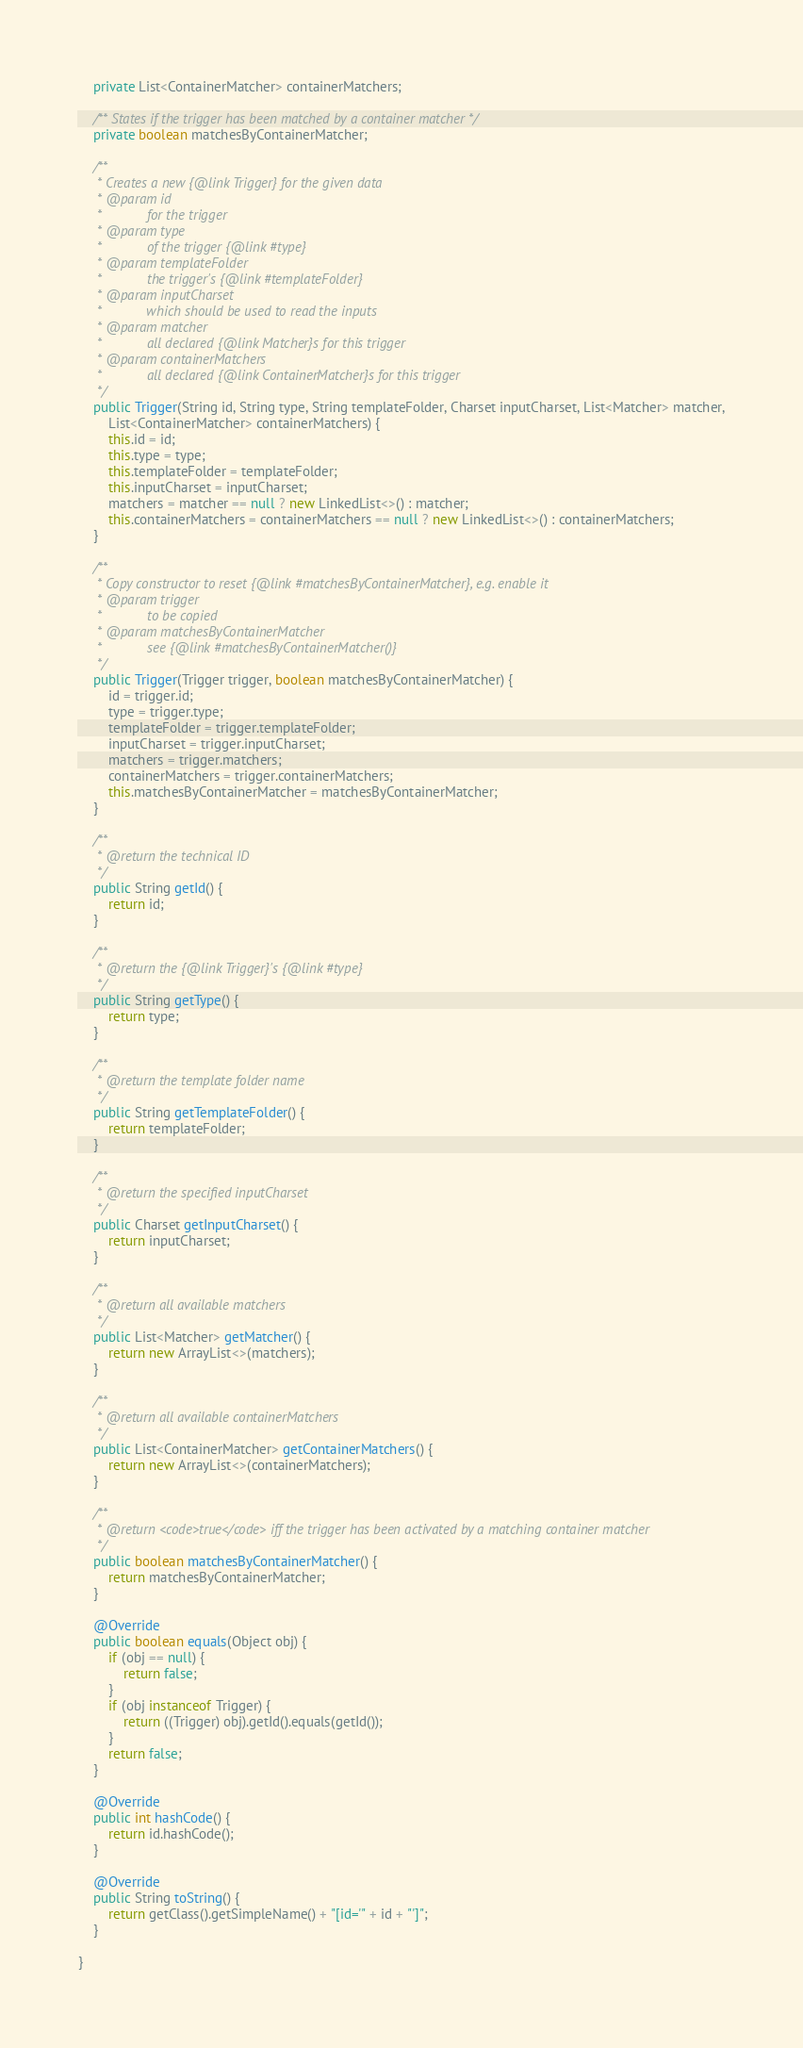<code> <loc_0><loc_0><loc_500><loc_500><_Java_>    private List<ContainerMatcher> containerMatchers;

    /** States if the trigger has been matched by a container matcher */
    private boolean matchesByContainerMatcher;

    /**
     * Creates a new {@link Trigger} for the given data
     * @param id
     *            for the trigger
     * @param type
     *            of the trigger {@link #type}
     * @param templateFolder
     *            the trigger's {@link #templateFolder}
     * @param inputCharset
     *            which should be used to read the inputs
     * @param matcher
     *            all declared {@link Matcher}s for this trigger
     * @param containerMatchers
     *            all declared {@link ContainerMatcher}s for this trigger
     */
    public Trigger(String id, String type, String templateFolder, Charset inputCharset, List<Matcher> matcher,
        List<ContainerMatcher> containerMatchers) {
        this.id = id;
        this.type = type;
        this.templateFolder = templateFolder;
        this.inputCharset = inputCharset;
        matchers = matcher == null ? new LinkedList<>() : matcher;
        this.containerMatchers = containerMatchers == null ? new LinkedList<>() : containerMatchers;
    }

    /**
     * Copy constructor to reset {@link #matchesByContainerMatcher}, e.g. enable it
     * @param trigger
     *            to be copied
     * @param matchesByContainerMatcher
     *            see {@link #matchesByContainerMatcher()}
     */
    public Trigger(Trigger trigger, boolean matchesByContainerMatcher) {
        id = trigger.id;
        type = trigger.type;
        templateFolder = trigger.templateFolder;
        inputCharset = trigger.inputCharset;
        matchers = trigger.matchers;
        containerMatchers = trigger.containerMatchers;
        this.matchesByContainerMatcher = matchesByContainerMatcher;
    }

    /**
     * @return the technical ID
     */
    public String getId() {
        return id;
    }

    /**
     * @return the {@link Trigger}'s {@link #type}
     */
    public String getType() {
        return type;
    }

    /**
     * @return the template folder name
     */
    public String getTemplateFolder() {
        return templateFolder;
    }

    /**
     * @return the specified inputCharset
     */
    public Charset getInputCharset() {
        return inputCharset;
    }

    /**
     * @return all available matchers
     */
    public List<Matcher> getMatcher() {
        return new ArrayList<>(matchers);
    }

    /**
     * @return all available containerMatchers
     */
    public List<ContainerMatcher> getContainerMatchers() {
        return new ArrayList<>(containerMatchers);
    }

    /**
     * @return <code>true</code> iff the trigger has been activated by a matching container matcher
     */
    public boolean matchesByContainerMatcher() {
        return matchesByContainerMatcher;
    }

    @Override
    public boolean equals(Object obj) {
        if (obj == null) {
            return false;
        }
        if (obj instanceof Trigger) {
            return ((Trigger) obj).getId().equals(getId());
        }
        return false;
    }

    @Override
    public int hashCode() {
        return id.hashCode();
    }

    @Override
    public String toString() {
        return getClass().getSimpleName() + "[id='" + id + "']";
    }

}
</code> 